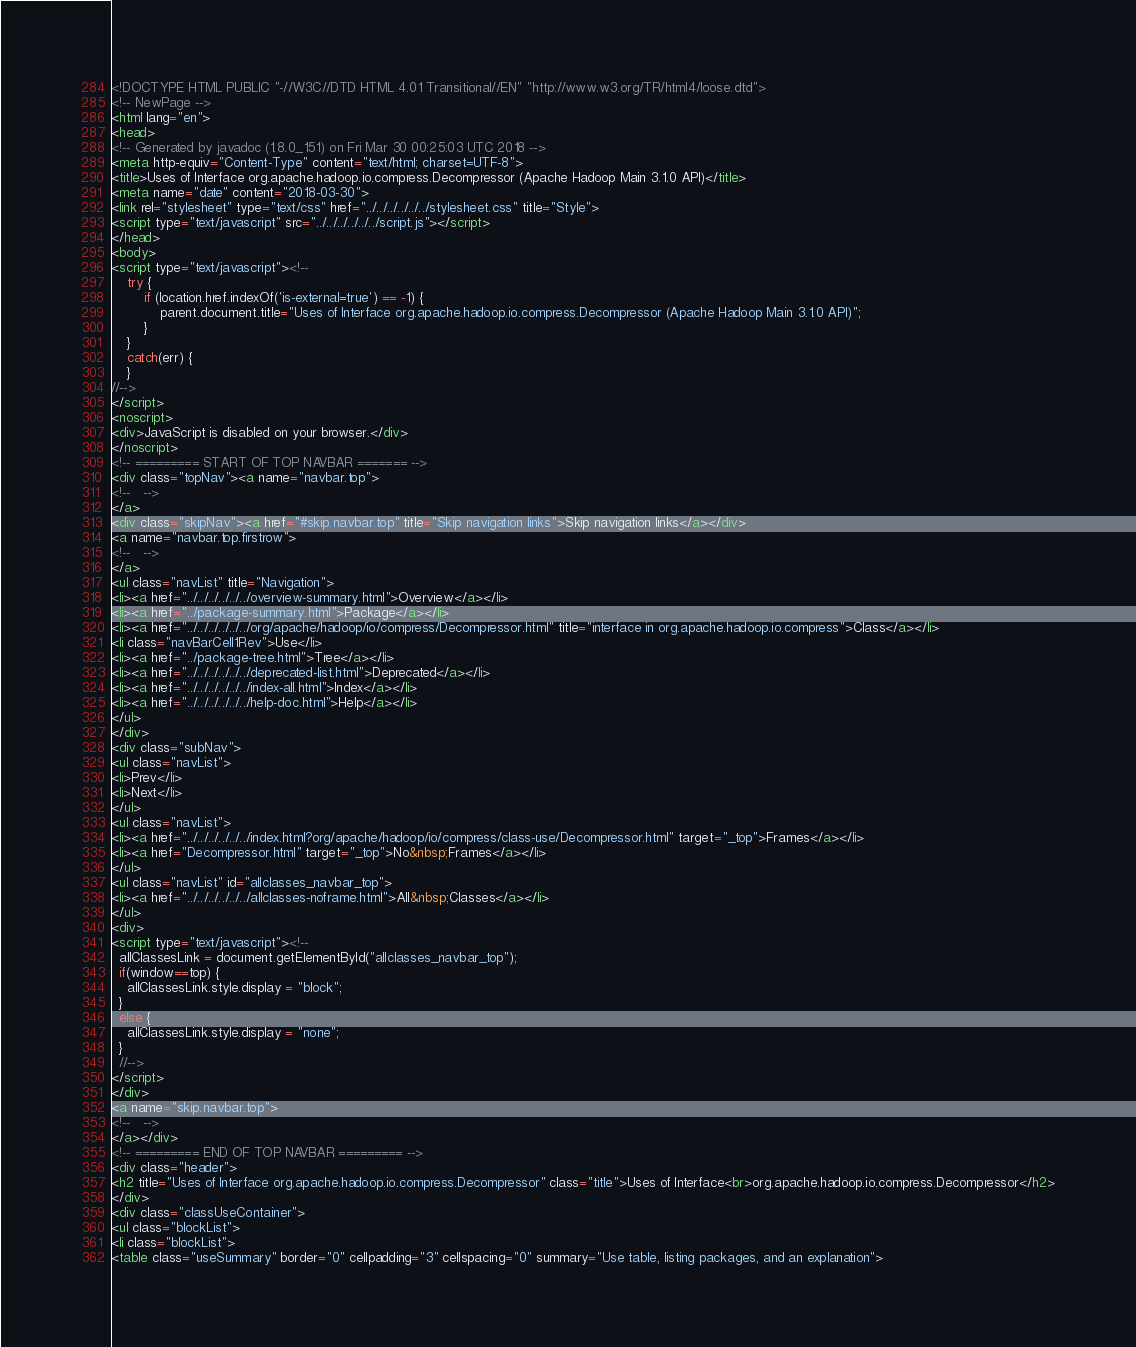Convert code to text. <code><loc_0><loc_0><loc_500><loc_500><_HTML_><!DOCTYPE HTML PUBLIC "-//W3C//DTD HTML 4.01 Transitional//EN" "http://www.w3.org/TR/html4/loose.dtd">
<!-- NewPage -->
<html lang="en">
<head>
<!-- Generated by javadoc (1.8.0_151) on Fri Mar 30 00:25:03 UTC 2018 -->
<meta http-equiv="Content-Type" content="text/html; charset=UTF-8">
<title>Uses of Interface org.apache.hadoop.io.compress.Decompressor (Apache Hadoop Main 3.1.0 API)</title>
<meta name="date" content="2018-03-30">
<link rel="stylesheet" type="text/css" href="../../../../../../stylesheet.css" title="Style">
<script type="text/javascript" src="../../../../../../script.js"></script>
</head>
<body>
<script type="text/javascript"><!--
    try {
        if (location.href.indexOf('is-external=true') == -1) {
            parent.document.title="Uses of Interface org.apache.hadoop.io.compress.Decompressor (Apache Hadoop Main 3.1.0 API)";
        }
    }
    catch(err) {
    }
//-->
</script>
<noscript>
<div>JavaScript is disabled on your browser.</div>
</noscript>
<!-- ========= START OF TOP NAVBAR ======= -->
<div class="topNav"><a name="navbar.top">
<!--   -->
</a>
<div class="skipNav"><a href="#skip.navbar.top" title="Skip navigation links">Skip navigation links</a></div>
<a name="navbar.top.firstrow">
<!--   -->
</a>
<ul class="navList" title="Navigation">
<li><a href="../../../../../../overview-summary.html">Overview</a></li>
<li><a href="../package-summary.html">Package</a></li>
<li><a href="../../../../../../org/apache/hadoop/io/compress/Decompressor.html" title="interface in org.apache.hadoop.io.compress">Class</a></li>
<li class="navBarCell1Rev">Use</li>
<li><a href="../package-tree.html">Tree</a></li>
<li><a href="../../../../../../deprecated-list.html">Deprecated</a></li>
<li><a href="../../../../../../index-all.html">Index</a></li>
<li><a href="../../../../../../help-doc.html">Help</a></li>
</ul>
</div>
<div class="subNav">
<ul class="navList">
<li>Prev</li>
<li>Next</li>
</ul>
<ul class="navList">
<li><a href="../../../../../../index.html?org/apache/hadoop/io/compress/class-use/Decompressor.html" target="_top">Frames</a></li>
<li><a href="Decompressor.html" target="_top">No&nbsp;Frames</a></li>
</ul>
<ul class="navList" id="allclasses_navbar_top">
<li><a href="../../../../../../allclasses-noframe.html">All&nbsp;Classes</a></li>
</ul>
<div>
<script type="text/javascript"><!--
  allClassesLink = document.getElementById("allclasses_navbar_top");
  if(window==top) {
    allClassesLink.style.display = "block";
  }
  else {
    allClassesLink.style.display = "none";
  }
  //-->
</script>
</div>
<a name="skip.navbar.top">
<!--   -->
</a></div>
<!-- ========= END OF TOP NAVBAR ========= -->
<div class="header">
<h2 title="Uses of Interface org.apache.hadoop.io.compress.Decompressor" class="title">Uses of Interface<br>org.apache.hadoop.io.compress.Decompressor</h2>
</div>
<div class="classUseContainer">
<ul class="blockList">
<li class="blockList">
<table class="useSummary" border="0" cellpadding="3" cellspacing="0" summary="Use table, listing packages, and an explanation"></code> 